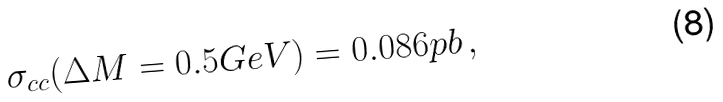Convert formula to latex. <formula><loc_0><loc_0><loc_500><loc_500>\sigma _ { c c } ( \Delta M = 0 . 5 G e V ) = 0 . 0 8 6 p b \, ,</formula> 